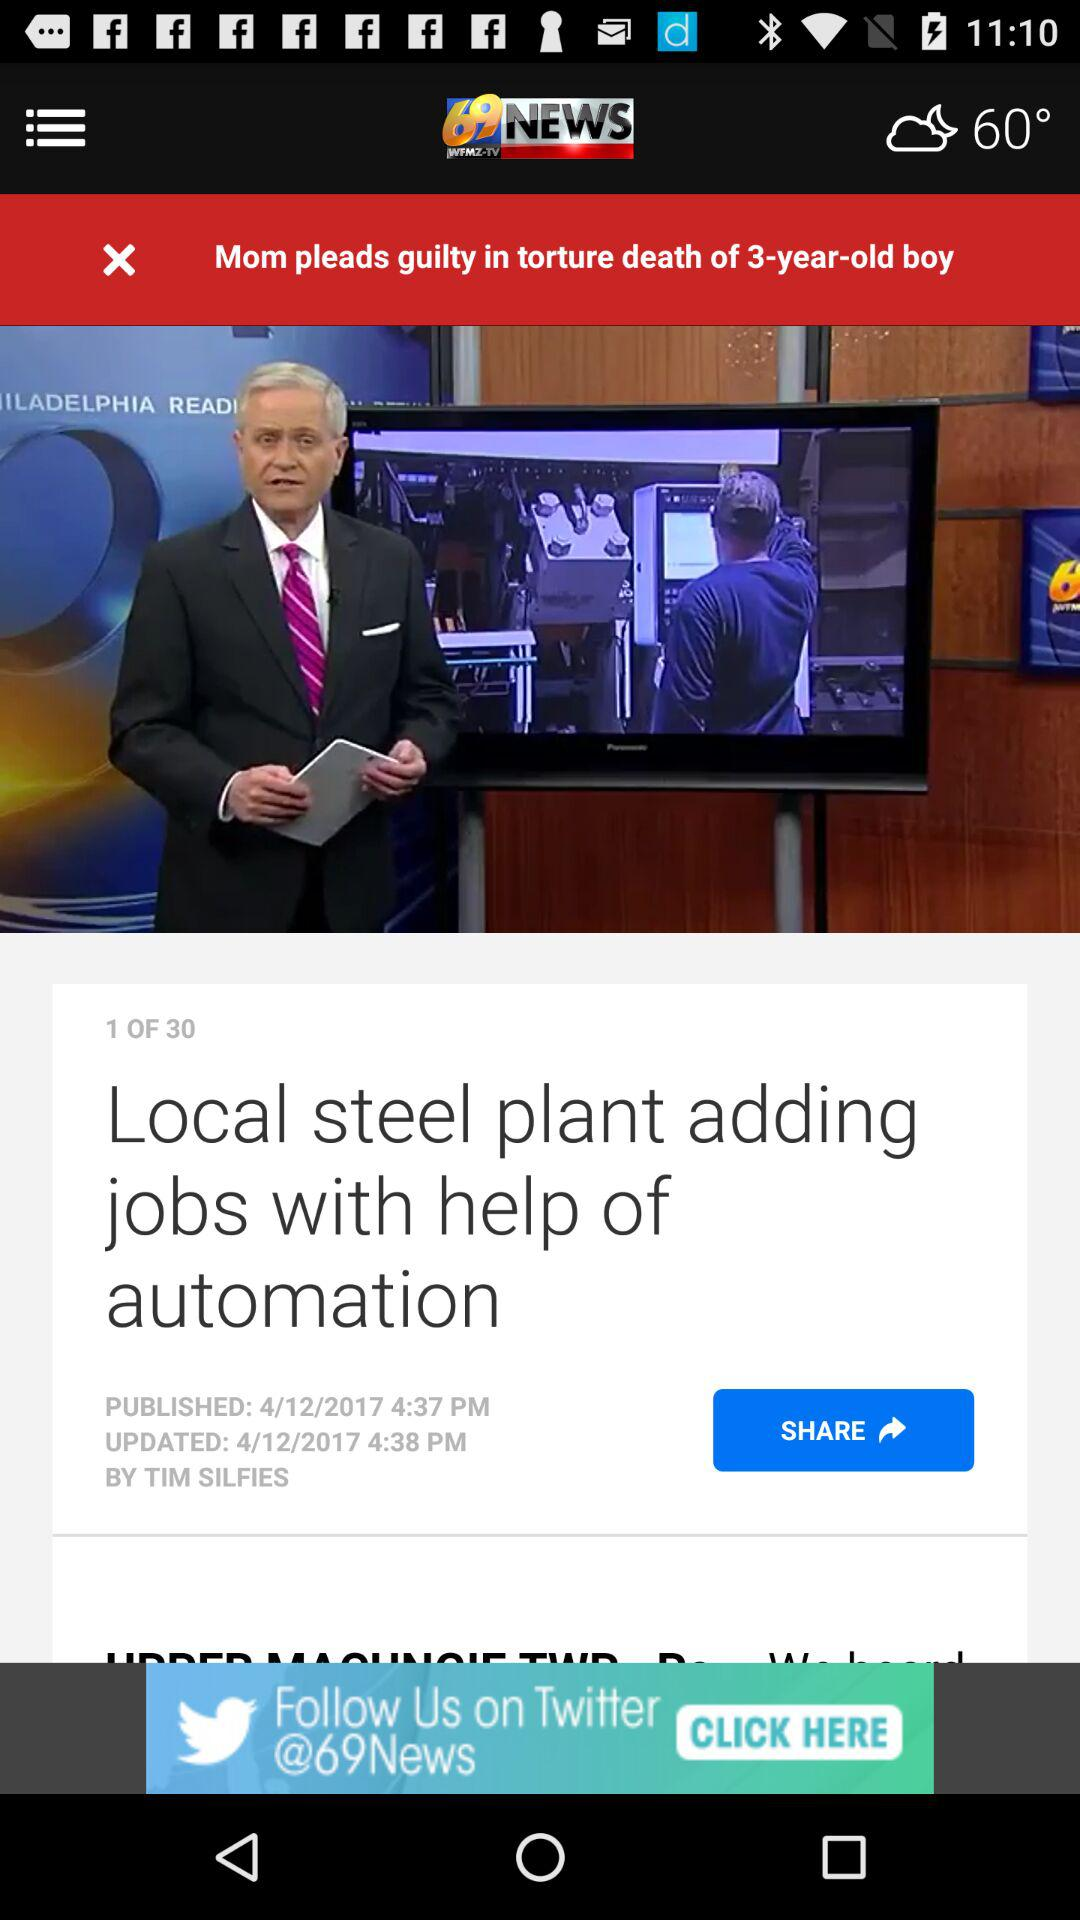On what date was the news about the "Local steel plant adding jobs with help of automation" updated? The news about the "Local steel plant adding jobs with help of automation" was updated on 4/12/2017. 